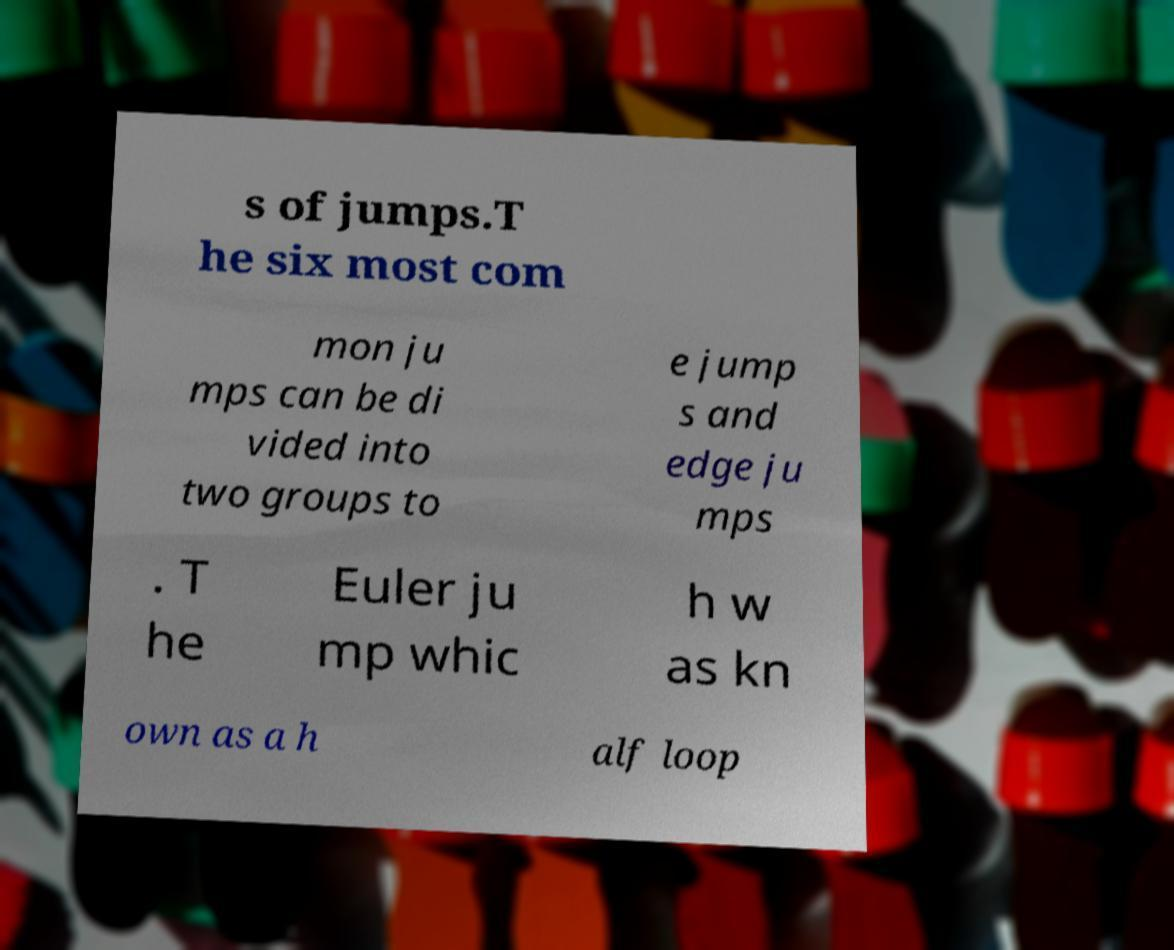Can you read and provide the text displayed in the image?This photo seems to have some interesting text. Can you extract and type it out for me? s of jumps.T he six most com mon ju mps can be di vided into two groups to e jump s and edge ju mps . T he Euler ju mp whic h w as kn own as a h alf loop 